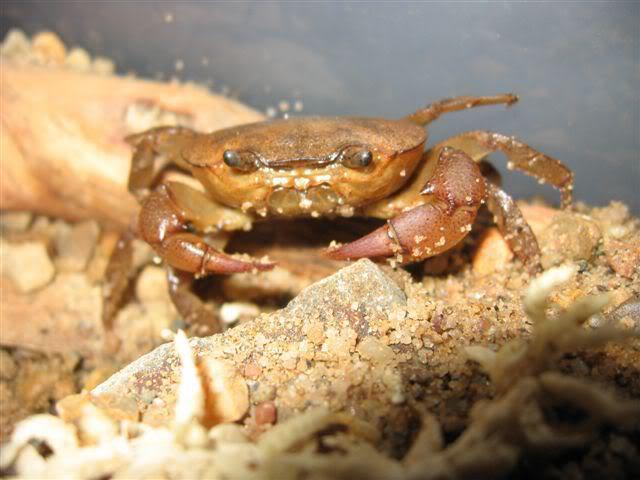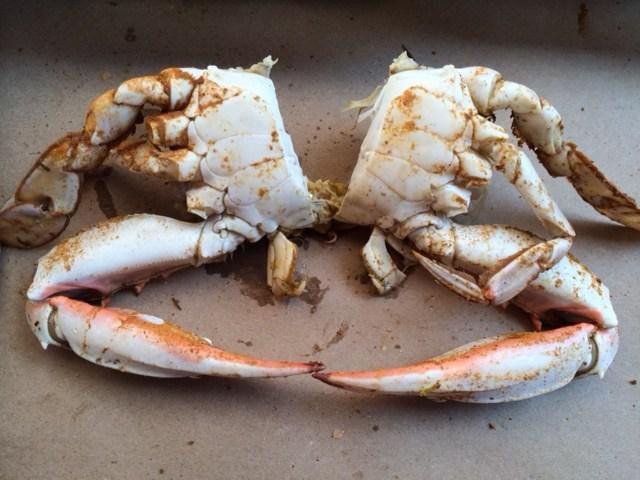The first image is the image on the left, the second image is the image on the right. For the images shown, is this caption "Several cooked crabs sit together in at least one of the images." true? Answer yes or no. No. The first image is the image on the left, the second image is the image on the right. Considering the images on both sides, is "There are exactly two crabs." valid? Answer yes or no. Yes. 